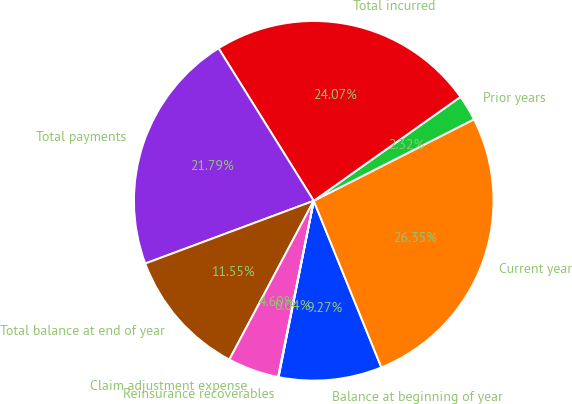<chart> <loc_0><loc_0><loc_500><loc_500><pie_chart><fcel>Balance at beginning of year<fcel>Current year<fcel>Prior years<fcel>Total incurred<fcel>Total payments<fcel>Total balance at end of year<fcel>Claim adjustment expense<fcel>Reinsurance recoverables<nl><fcel>9.27%<fcel>26.35%<fcel>2.32%<fcel>24.07%<fcel>21.79%<fcel>11.55%<fcel>4.6%<fcel>0.04%<nl></chart> 